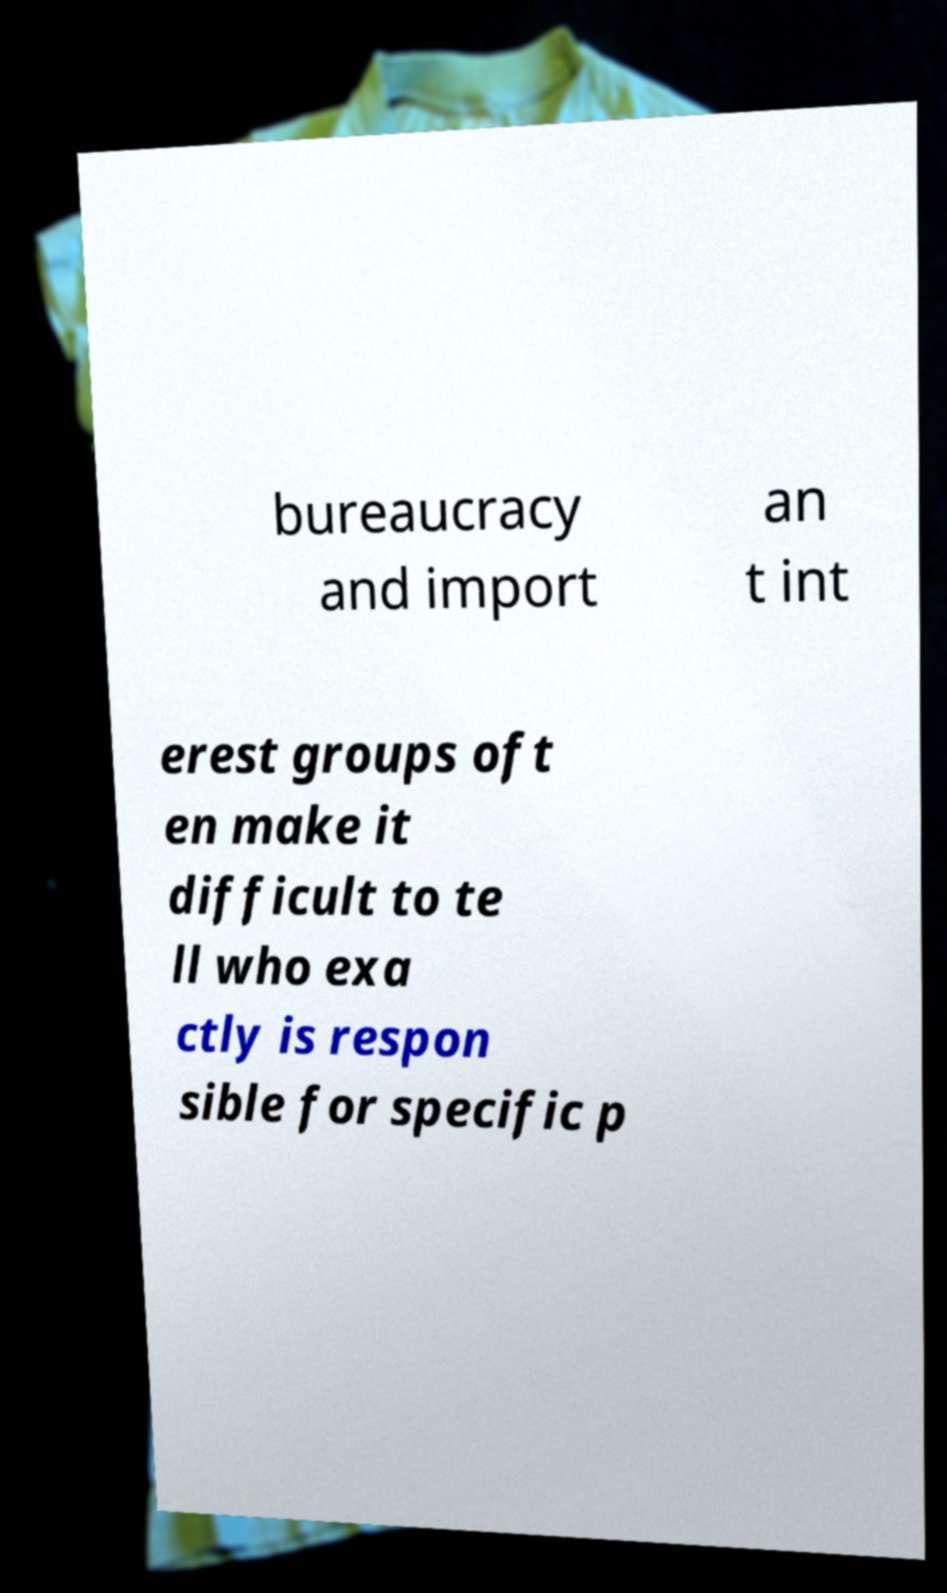I need the written content from this picture converted into text. Can you do that? bureaucracy and import an t int erest groups oft en make it difficult to te ll who exa ctly is respon sible for specific p 